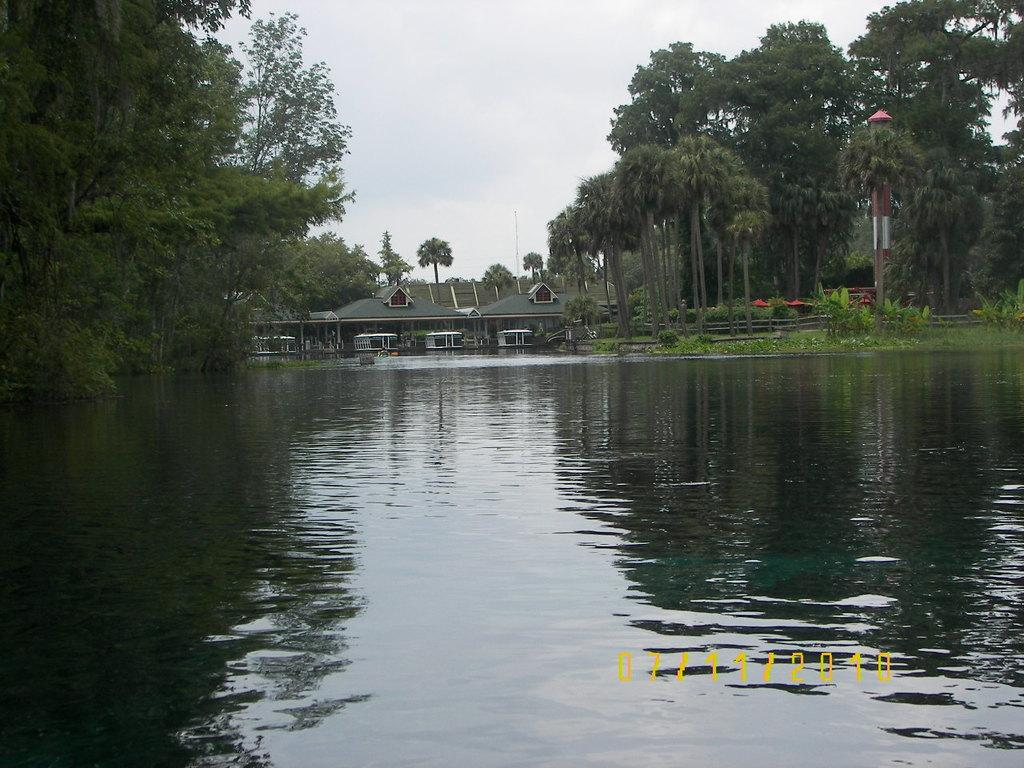What is present in the image that is related to water? There is water visible in the image. What type of structure can be seen in the image? There is a house in the image. What kind of barrier is present in the image? There is a wooden fence in the image. What type of vegetation is present in the image? There are trees in the image. What can be seen in the sky in the image? Clouds are visible in the sky. What type of cord is hanging from the trees in the image? There is no cord hanging from the trees in the image; only trees, water, a house, a wooden fence, and clouds in the sky are present. 